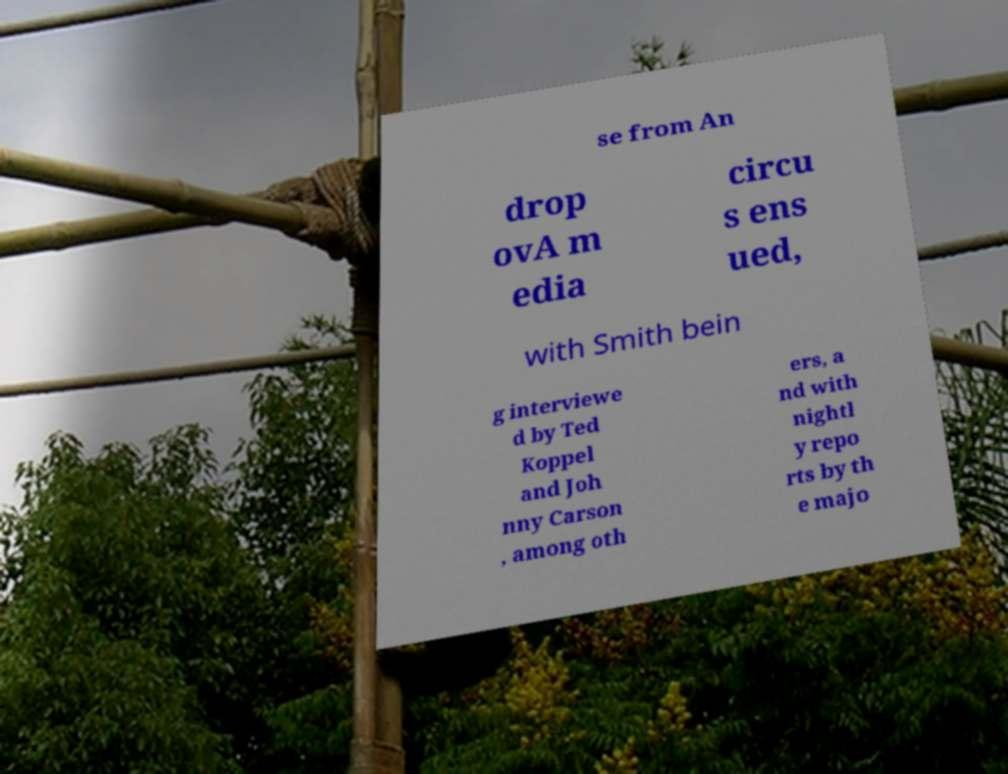There's text embedded in this image that I need extracted. Can you transcribe it verbatim? se from An drop ovA m edia circu s ens ued, with Smith bein g interviewe d by Ted Koppel and Joh nny Carson , among oth ers, a nd with nightl y repo rts by th e majo 